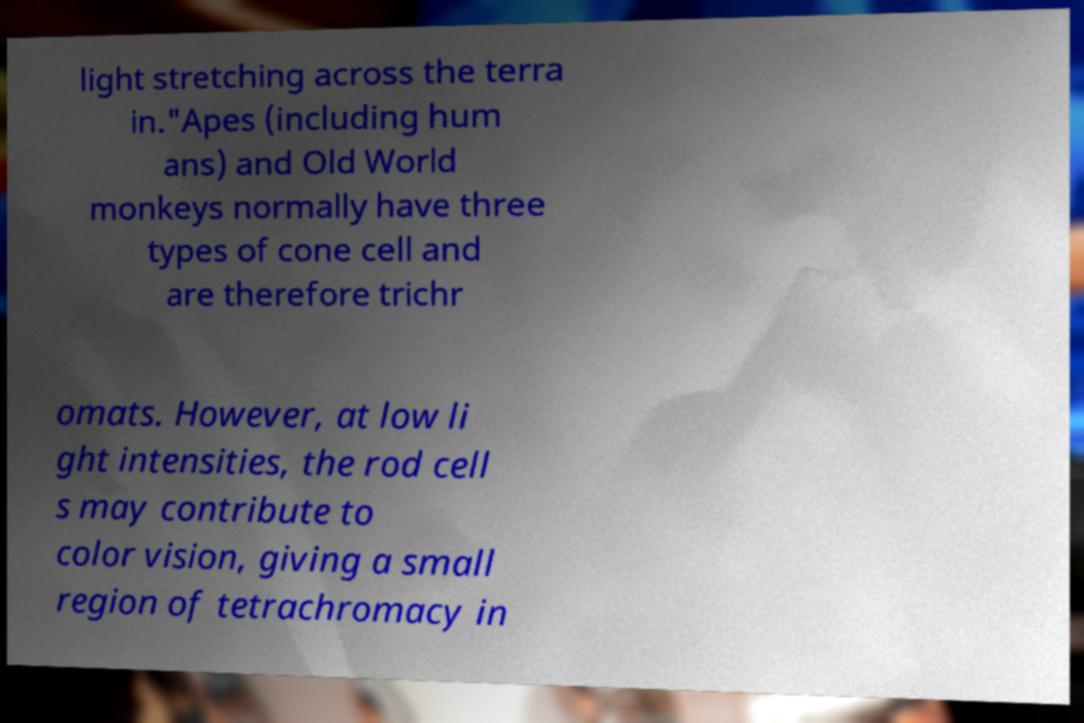Please read and relay the text visible in this image. What does it say? light stretching across the terra in."Apes (including hum ans) and Old World monkeys normally have three types of cone cell and are therefore trichr omats. However, at low li ght intensities, the rod cell s may contribute to color vision, giving a small region of tetrachromacy in 